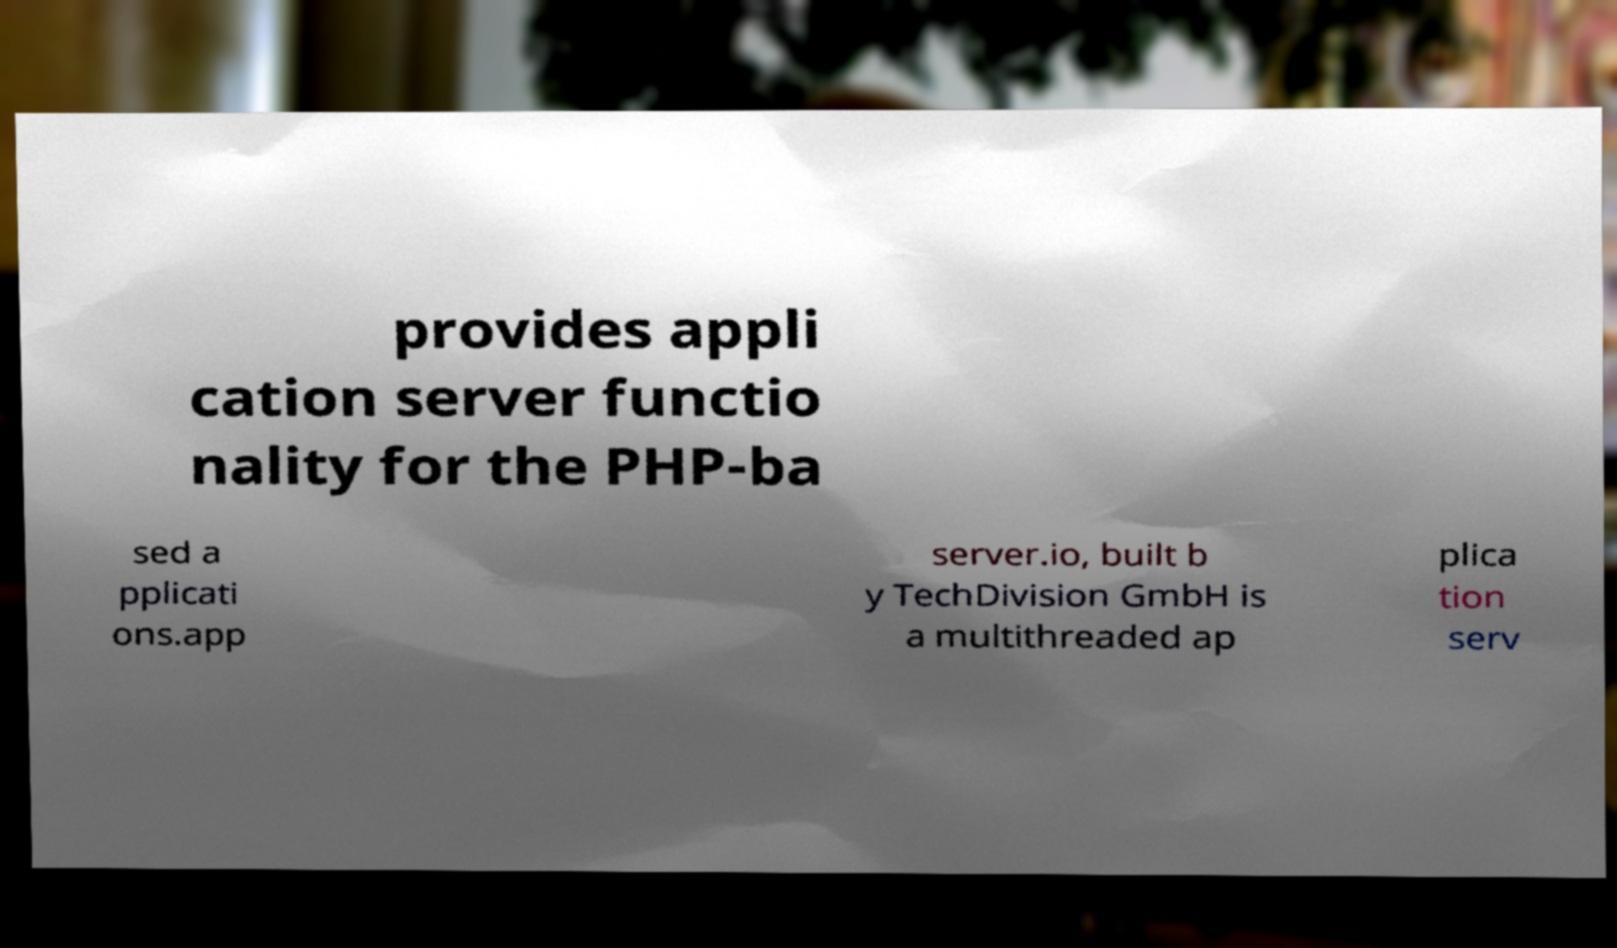Please read and relay the text visible in this image. What does it say? provides appli cation server functio nality for the PHP-ba sed a pplicati ons.app server.io, built b y TechDivision GmbH is a multithreaded ap plica tion serv 